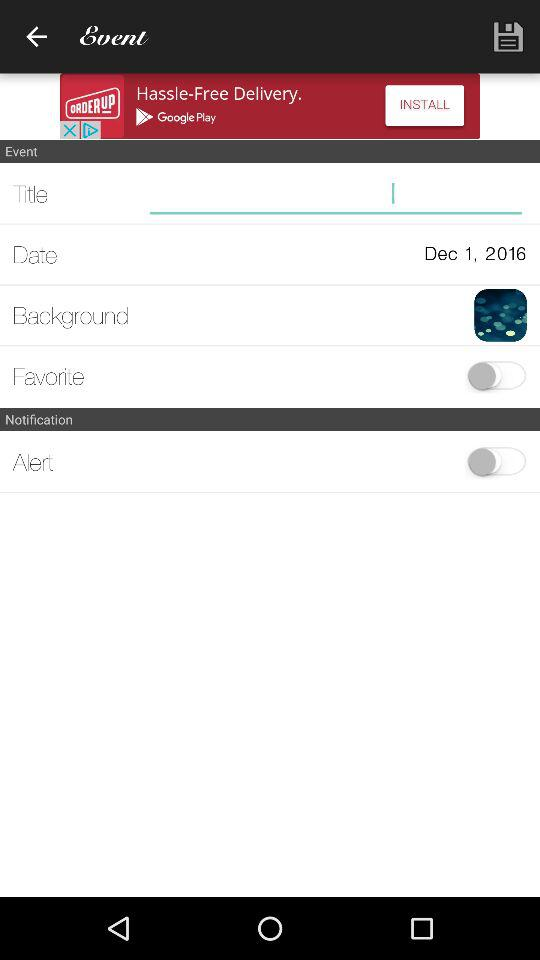What is the date and year of the event? The date of the event is December 1 and the year is 2016. 